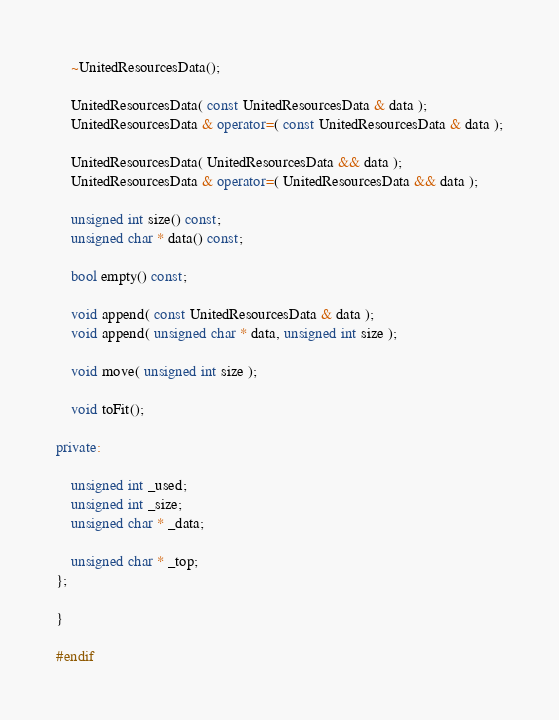<code> <loc_0><loc_0><loc_500><loc_500><_C++_>	~UnitedResourcesData();

	UnitedResourcesData( const UnitedResourcesData & data );
	UnitedResourcesData & operator=( const UnitedResourcesData & data );

	UnitedResourcesData( UnitedResourcesData && data );
	UnitedResourcesData & operator=( UnitedResourcesData && data );

	unsigned int size() const;
	unsigned char * data() const;

	bool empty() const;

	void append( const UnitedResourcesData & data );
	void append( unsigned char * data, unsigned int size );

	void move( unsigned int size );

	void toFit();

private:

	unsigned int _used;
	unsigned int _size;
	unsigned char * _data;

	unsigned char * _top;
};

}

#endif</code> 